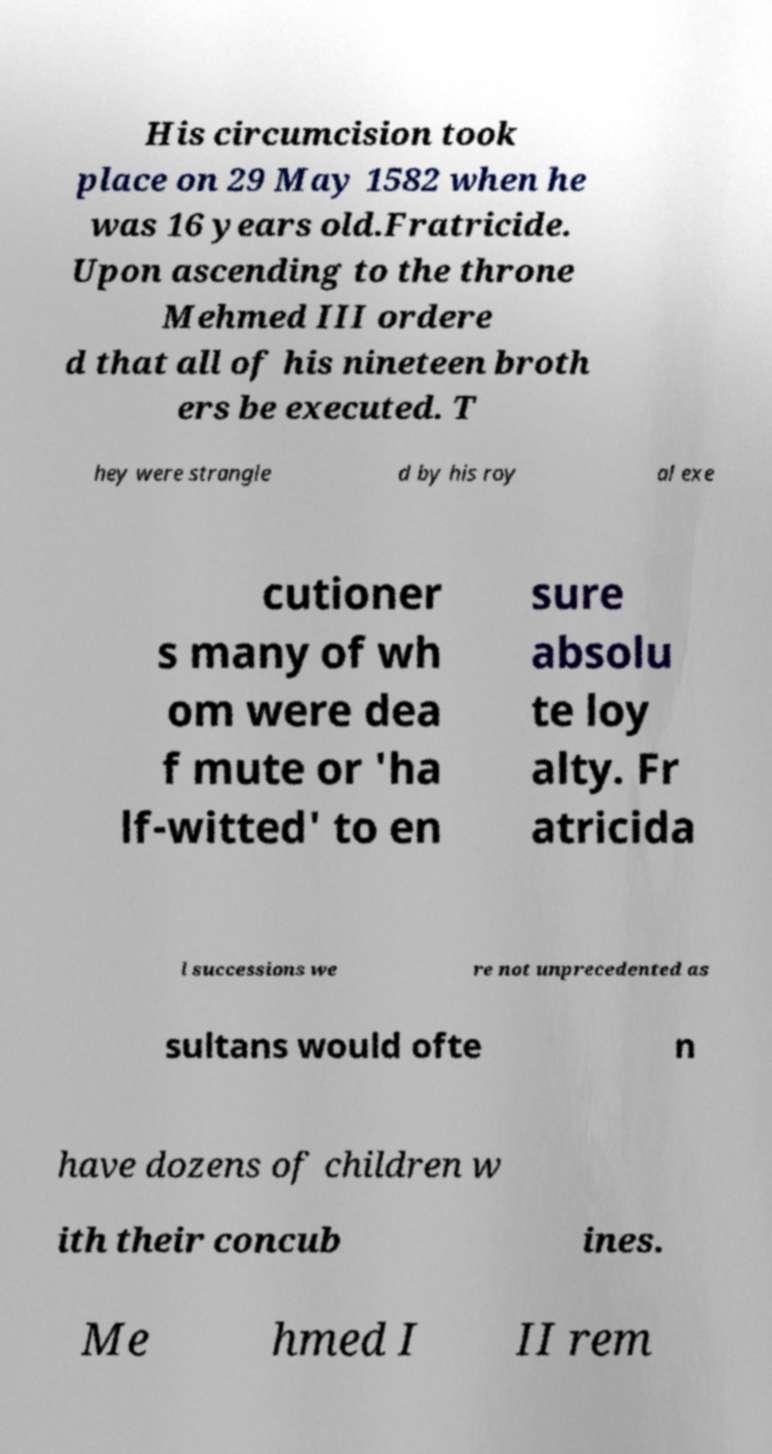Can you read and provide the text displayed in the image?This photo seems to have some interesting text. Can you extract and type it out for me? His circumcision took place on 29 May 1582 when he was 16 years old.Fratricide. Upon ascending to the throne Mehmed III ordere d that all of his nineteen broth ers be executed. T hey were strangle d by his roy al exe cutioner s many of wh om were dea f mute or 'ha lf-witted' to en sure absolu te loy alty. Fr atricida l successions we re not unprecedented as sultans would ofte n have dozens of children w ith their concub ines. Me hmed I II rem 